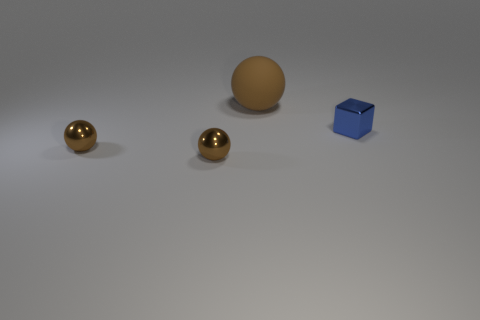Is the number of balls that are in front of the brown rubber sphere greater than the number of brown rubber balls that are behind the small blue metal object?
Ensure brevity in your answer.  Yes. Is there any other thing that has the same size as the matte object?
Offer a very short reply. No. There is a brown rubber ball; what number of blue metal things are left of it?
Make the answer very short. 0. Are there any other things that are the same shape as the tiny blue object?
Keep it short and to the point. No. There is a tiny thing that is to the right of the big brown rubber ball; what shape is it?
Your answer should be very brief. Cube. What number of other big brown objects have the same shape as the big object?
Provide a succinct answer. 0. There is a small object that is to the right of the matte object; does it have the same color as the sphere behind the blue metal object?
Ensure brevity in your answer.  No. How many objects are either small green shiny blocks or tiny spheres?
Keep it short and to the point. 2. What number of blue blocks have the same material as the tiny blue object?
Your answer should be compact. 0. Are there fewer small yellow metal cylinders than small metallic blocks?
Provide a succinct answer. Yes. 